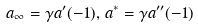<formula> <loc_0><loc_0><loc_500><loc_500>a _ { \infty } = \gamma a ^ { \prime } ( - 1 ) , \, a ^ { * } = \gamma a ^ { \prime \prime } ( - 1 )</formula> 